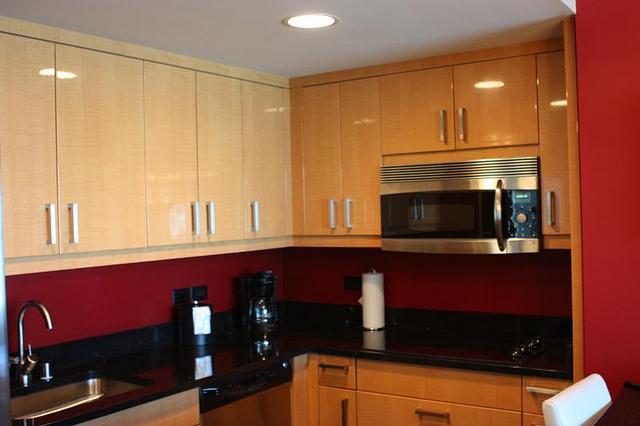Do the cabinets match?
Concise answer only. Yes. What is the white thing on the counter?
Concise answer only. Paper towels. What room is this?
Short answer required. Kitchen. 